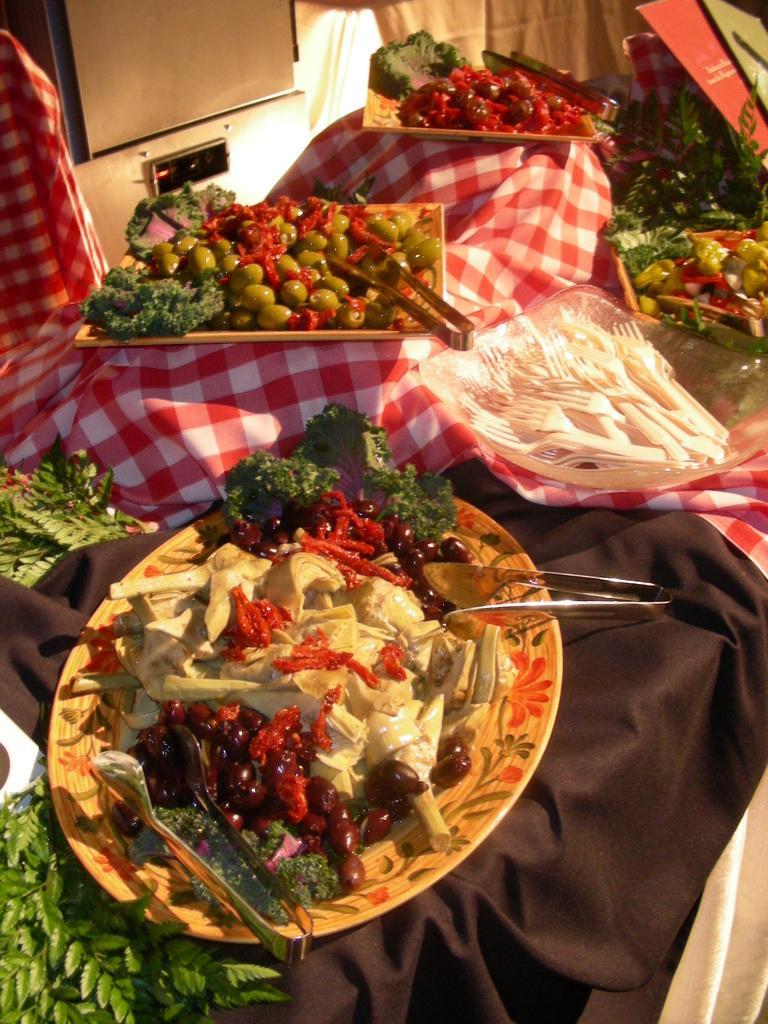Please provide a concise description of this image. There are vegetables and fruits arranged on the plates. These plates are arranged on the table, on which there are cloths. In the background, there is a light. 